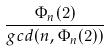<formula> <loc_0><loc_0><loc_500><loc_500>\frac { \Phi _ { n } ( 2 ) } { g c d ( n , \Phi _ { n } ( 2 ) ) }</formula> 